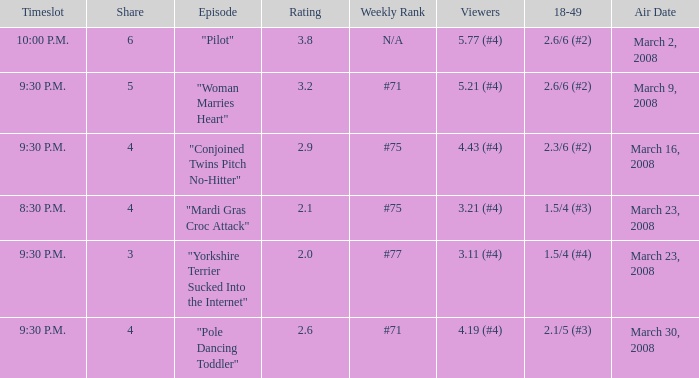What is the total ratings on share less than 4? 1.0. 